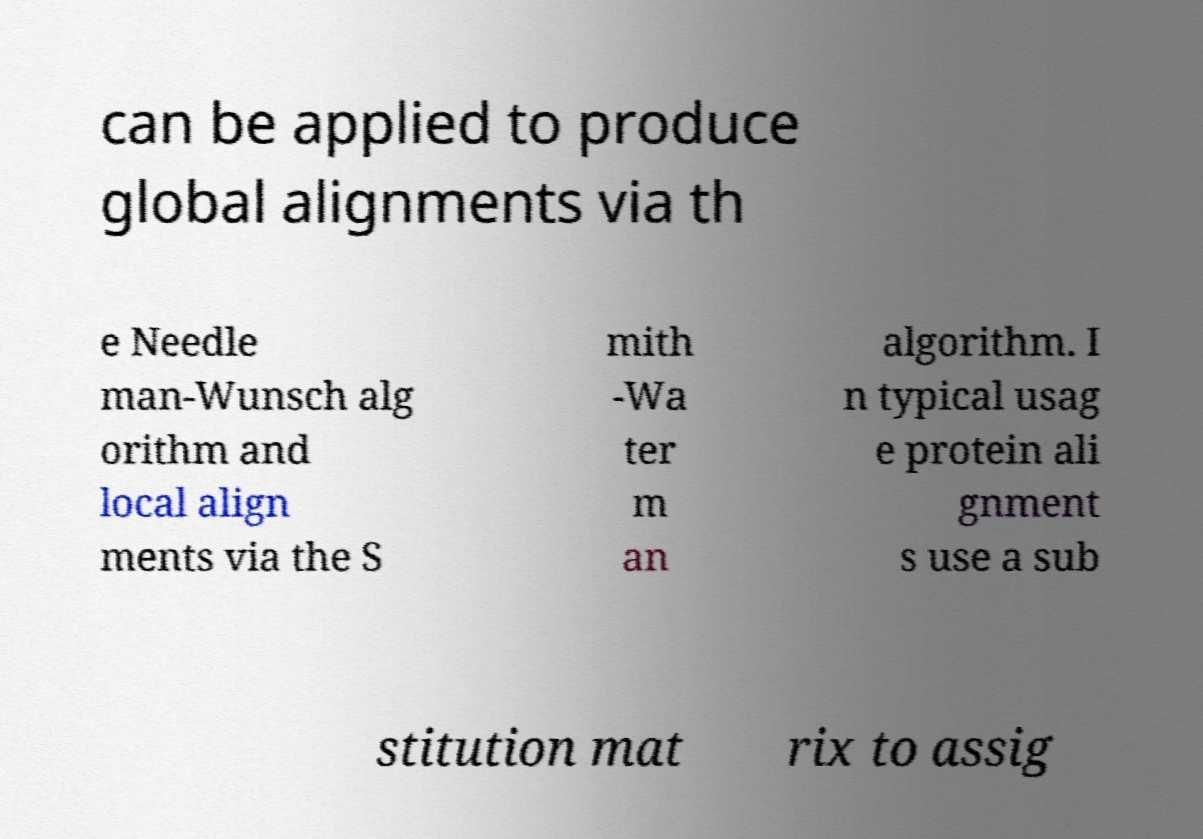There's text embedded in this image that I need extracted. Can you transcribe it verbatim? can be applied to produce global alignments via th e Needle man-Wunsch alg orithm and local align ments via the S mith -Wa ter m an algorithm. I n typical usag e protein ali gnment s use a sub stitution mat rix to assig 